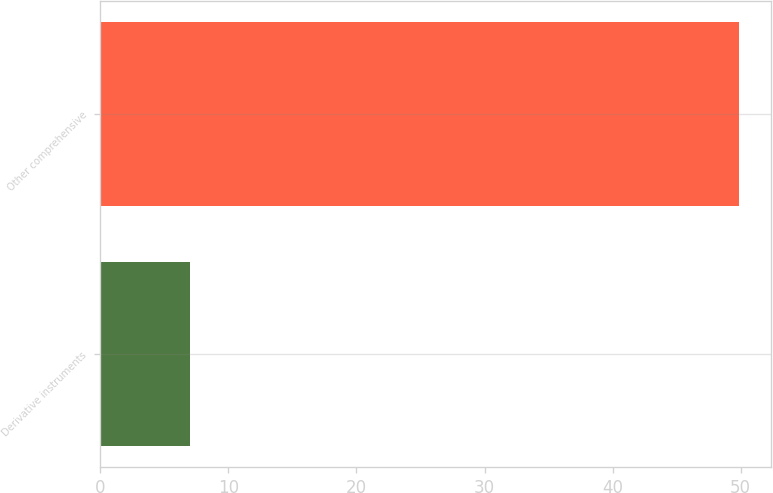Convert chart to OTSL. <chart><loc_0><loc_0><loc_500><loc_500><bar_chart><fcel>Derivative instruments<fcel>Other comprehensive<nl><fcel>7<fcel>49.9<nl></chart> 